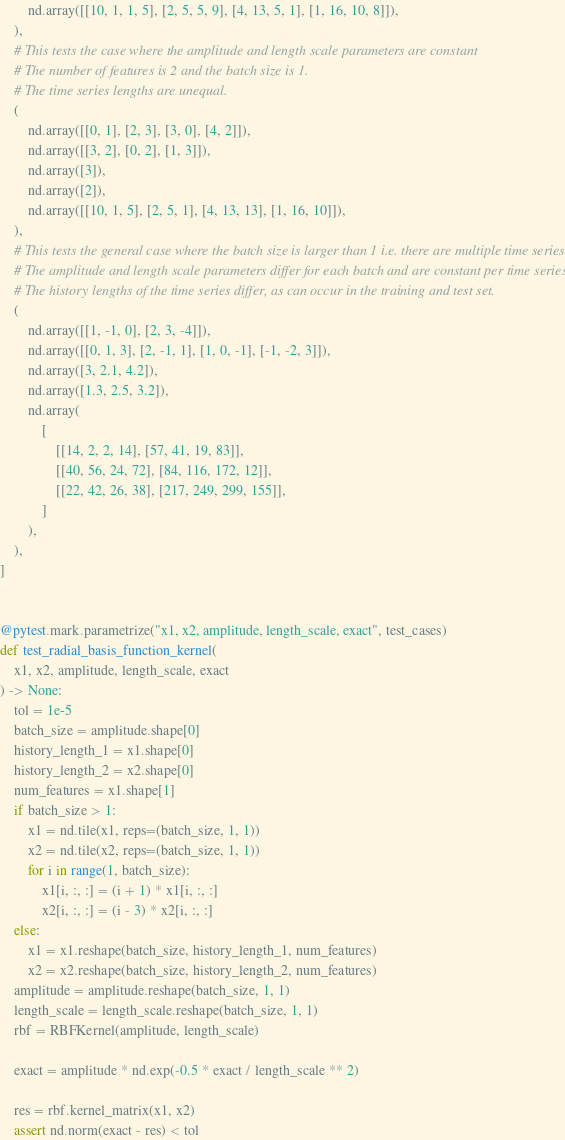Convert code to text. <code><loc_0><loc_0><loc_500><loc_500><_Python_>        nd.array([[10, 1, 1, 5], [2, 5, 5, 9], [4, 13, 5, 1], [1, 16, 10, 8]]),
    ),
    # This tests the case where the amplitude and length scale parameters are constant
    # The number of features is 2 and the batch size is 1.
    # The time series lengths are unequal.
    (
        nd.array([[0, 1], [2, 3], [3, 0], [4, 2]]),
        nd.array([[3, 2], [0, 2], [1, 3]]),
        nd.array([3]),
        nd.array([2]),
        nd.array([[10, 1, 5], [2, 5, 1], [4, 13, 13], [1, 16, 10]]),
    ),
    # This tests the general case where the batch size is larger than 1 i.e. there are multiple time series.
    # The amplitude and length scale parameters differ for each batch and are constant per time series.
    # The history lengths of the time series differ, as can occur in the training and test set.
    (
        nd.array([[1, -1, 0], [2, 3, -4]]),
        nd.array([[0, 1, 3], [2, -1, 1], [1, 0, -1], [-1, -2, 3]]),
        nd.array([3, 2.1, 4.2]),
        nd.array([1.3, 2.5, 3.2]),
        nd.array(
            [
                [[14, 2, 2, 14], [57, 41, 19, 83]],
                [[40, 56, 24, 72], [84, 116, 172, 12]],
                [[22, 42, 26, 38], [217, 249, 299, 155]],
            ]
        ),
    ),
]


@pytest.mark.parametrize("x1, x2, amplitude, length_scale, exact", test_cases)
def test_radial_basis_function_kernel(
    x1, x2, amplitude, length_scale, exact
) -> None:
    tol = 1e-5
    batch_size = amplitude.shape[0]
    history_length_1 = x1.shape[0]
    history_length_2 = x2.shape[0]
    num_features = x1.shape[1]
    if batch_size > 1:
        x1 = nd.tile(x1, reps=(batch_size, 1, 1))
        x2 = nd.tile(x2, reps=(batch_size, 1, 1))
        for i in range(1, batch_size):
            x1[i, :, :] = (i + 1) * x1[i, :, :]
            x2[i, :, :] = (i - 3) * x2[i, :, :]
    else:
        x1 = x1.reshape(batch_size, history_length_1, num_features)
        x2 = x2.reshape(batch_size, history_length_2, num_features)
    amplitude = amplitude.reshape(batch_size, 1, 1)
    length_scale = length_scale.reshape(batch_size, 1, 1)
    rbf = RBFKernel(amplitude, length_scale)

    exact = amplitude * nd.exp(-0.5 * exact / length_scale ** 2)

    res = rbf.kernel_matrix(x1, x2)
    assert nd.norm(exact - res) < tol
</code> 